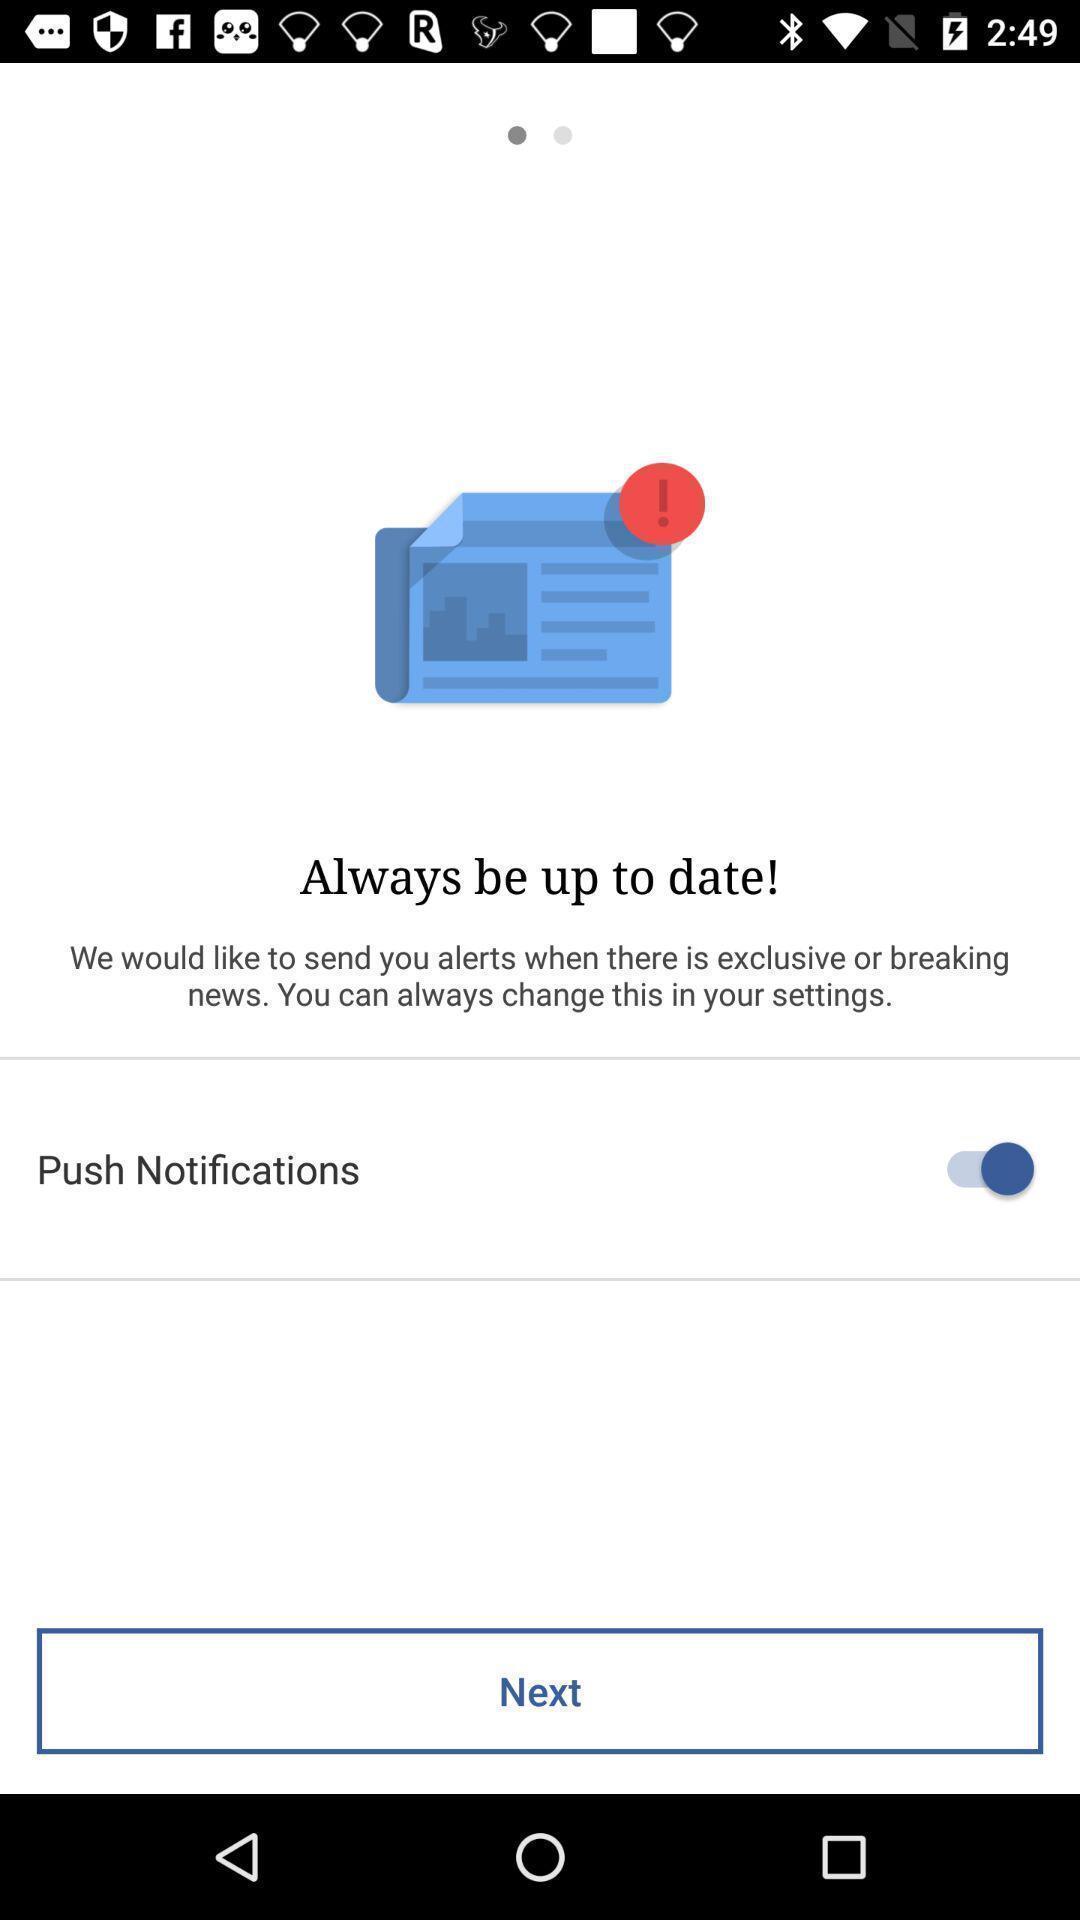Explain what's happening in this screen capture. Page displaying with notification alert option for news. 